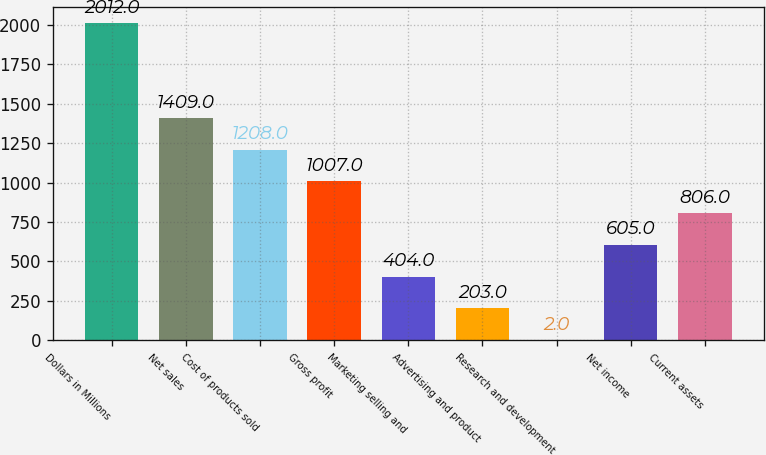Convert chart to OTSL. <chart><loc_0><loc_0><loc_500><loc_500><bar_chart><fcel>Dollars in Millions<fcel>Net sales<fcel>Cost of products sold<fcel>Gross profit<fcel>Marketing selling and<fcel>Advertising and product<fcel>Research and development<fcel>Net income<fcel>Current assets<nl><fcel>2012<fcel>1409<fcel>1208<fcel>1007<fcel>404<fcel>203<fcel>2<fcel>605<fcel>806<nl></chart> 